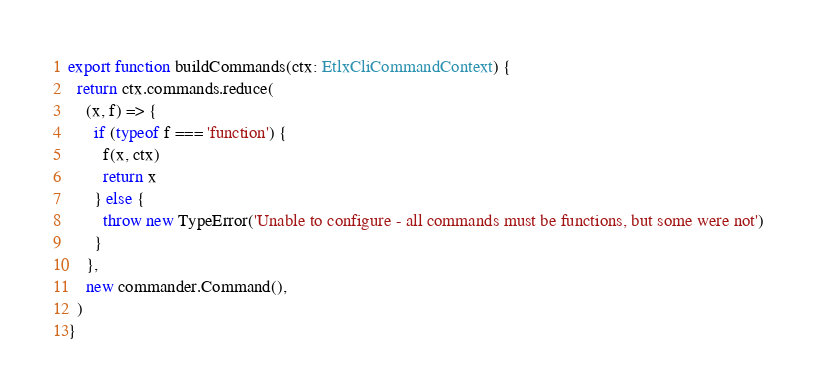Convert code to text. <code><loc_0><loc_0><loc_500><loc_500><_TypeScript_>

export function buildCommands(ctx: EtlxCliCommandContext) {
  return ctx.commands.reduce(
    (x, f) => {
      if (typeof f === 'function') {
        f(x, ctx)
        return x
      } else {
        throw new TypeError('Unable to configure - all commands must be functions, but some were not')
      }
    },
    new commander.Command(),
  )
}
</code> 